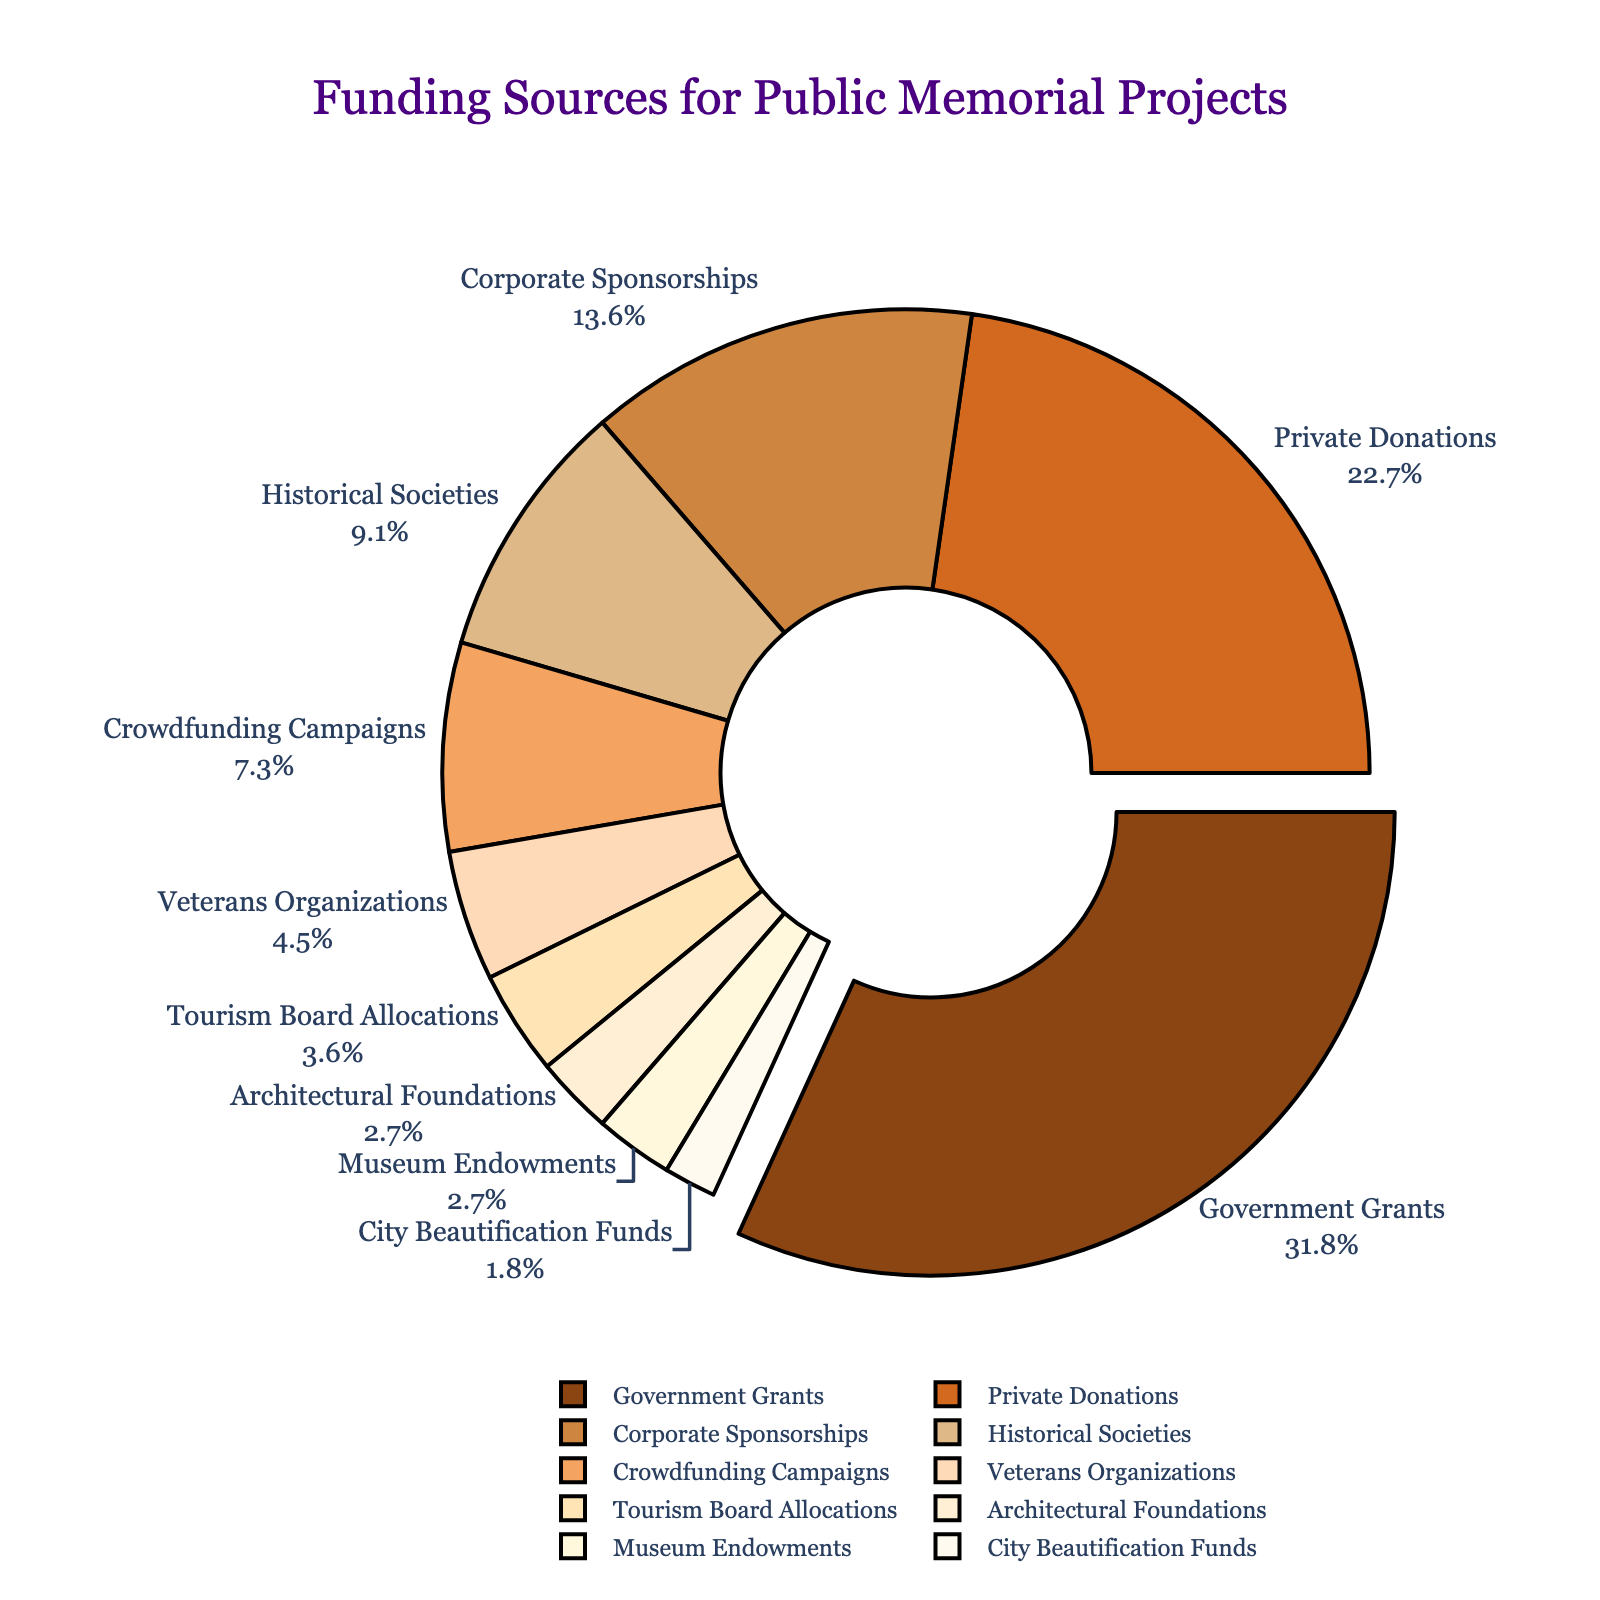Which funding source contributes the largest percentage to public memorial projects? The largest percentage is depicted by the slice that stands out (pulled out) visually from the pie chart. This slice represents Government Grants, which contributes 35%
Answer: Government Grants What is the total percentage contributed by Historical Societies, Crowdfunding Campaigns, Veterans Organizations, and Museum Endowments combined? To find the total percentage, add the individual percentages together: 10% (Historical Societies) + 8% (Crowdfunding Campaigns) + 5% (Veterans Organizations) + 3% (Museum Endowments) = 26%.
Answer: 26% Which two funding sources have the smallest contributions, and what is their combined percentage? The smallest contributions are indicated by the smallest slices on the pie chart. These slices represent City Beautification Funds (2%) and Architectural Foundations (3%). Their combined percentage is 2% + 3% = 5%.
Answer: City Beautification Funds and Architectural Foundations, 5% How much greater is the percentage of Government Grants compared to Corporate Sponsorships? The percentage of Government Grants is 35% and Corporate Sponsorships is 15%. The difference is 35% - 15% = 20%.
Answer: 20% What is the approximate visual angle of the slice corresponding to Private Donations? A full circle is 360 degrees. Private Donations constitute 25% of the total, so their angle is 25% of 360 degrees, which is 0.25 * 360 = 90 degrees.
Answer: 90 degrees Which segment has a darker shade of brown, Corporate Sponsorships or Historical Societies? By visually comparing the shades of brown used for the slices, Corporate Sponsorships (15%) has a darker shade than Historical Societies (10%).
Answer: Corporate Sponsorships Are Private Donations contributing more than twice the amount of City Beautification Funds? Private Donations contribute 25%, and City Beautification Funds contribute 2%. Since 25% is more than twice 2%, the answer is yes.
Answer: Yes What two funding sources together make up exactly 40% of the contributions? By examining pairs of segments, Private Donations (25%) and Corporate Sponsorships (15%) together make up 40%.
Answer: Private Donations and Corporate Sponsorships Which funding source contributes less than 5% but more than 2%? Checking the slices, Architectural Foundations (3%) fits this criterion.
Answer: Architectural Foundations How much more does the Tourism Board Allocations contribute compared to City Beautification Funds? Tourism Board Allocations contribute 4% and City Beautification Funds contribute 2%. The difference is 4% - 2% = 2%.
Answer: 2% 